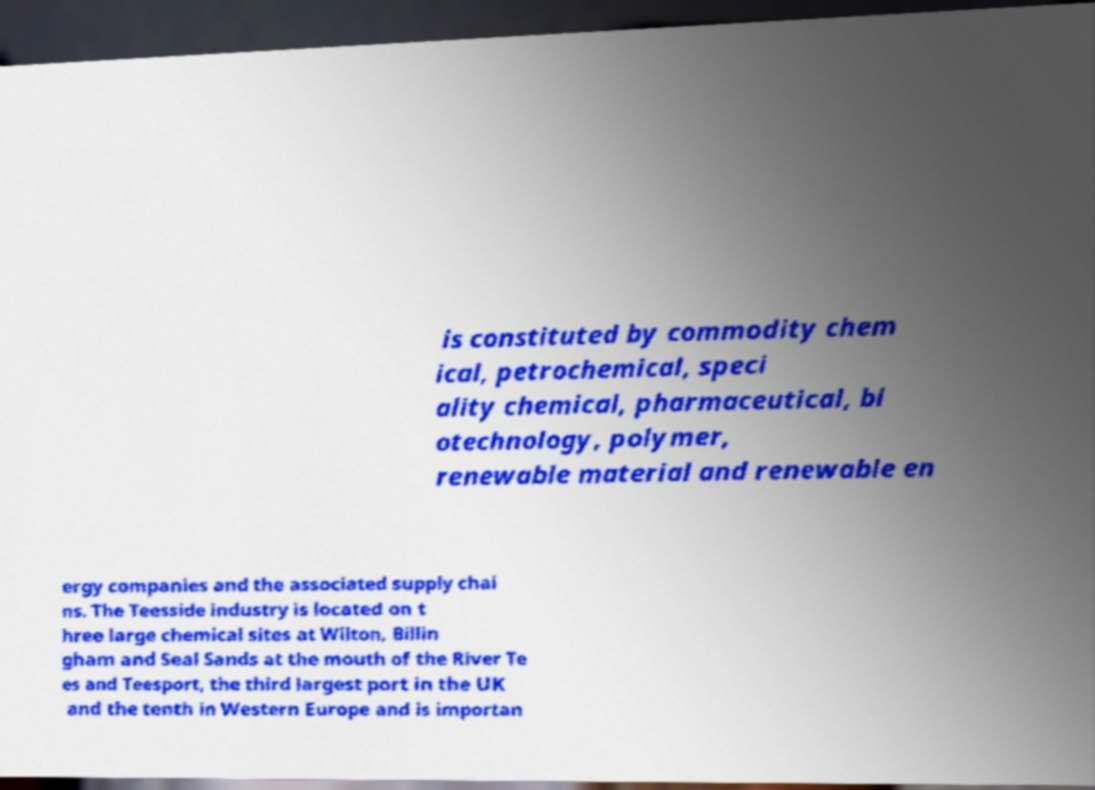Can you accurately transcribe the text from the provided image for me? is constituted by commodity chem ical, petrochemical, speci ality chemical, pharmaceutical, bi otechnology, polymer, renewable material and renewable en ergy companies and the associated supply chai ns. The Teesside industry is located on t hree large chemical sites at Wilton, Billin gham and Seal Sands at the mouth of the River Te es and Teesport, the third largest port in the UK and the tenth in Western Europe and is importan 